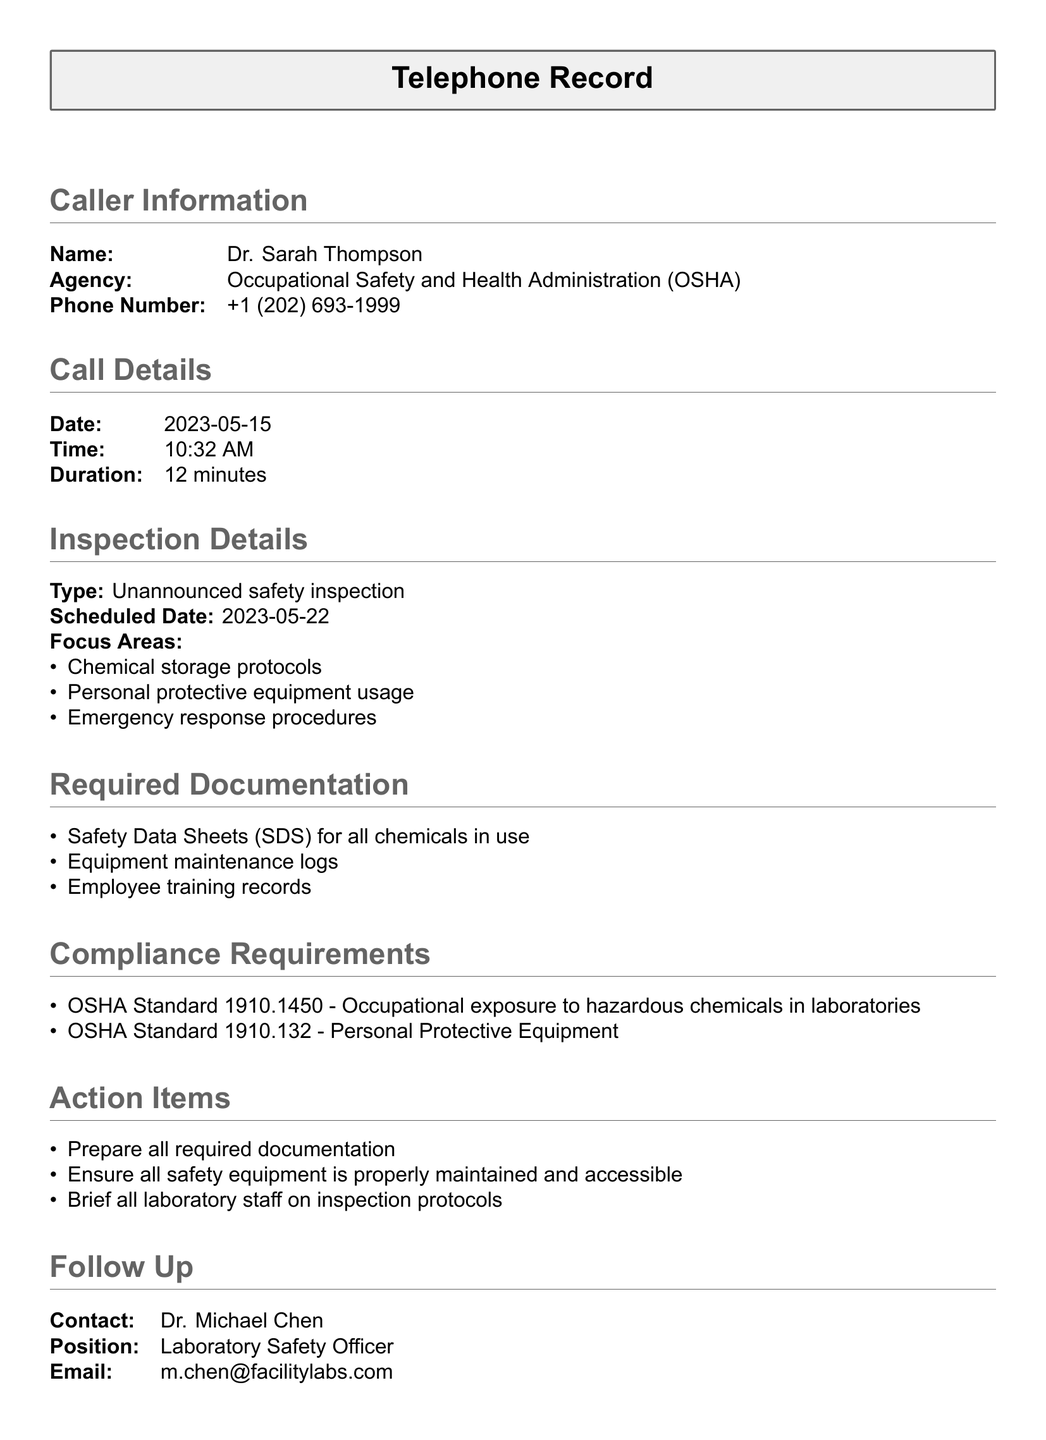What is the name of the caller? The caller's name is provided in the "Caller Information" section.
Answer: Dr. Sarah Thompson What agency does the caller represent? The agency is specified right after the caller's name.
Answer: Occupational Safety and Health Administration (OSHA) What is the date of the call? The date can be found in the "Call Details" section.
Answer: 2023-05-15 What type of inspection is scheduled? The type of inspection is listed under "Inspection Details."
Answer: Unannounced safety inspection How long was the call? The call duration is indicated in the "Call Details" section.
Answer: 12 minutes What are the focus areas of the inspection? The focus areas are listed as bullet points under "Inspection Details."
Answer: Chemical storage protocols, Personal protective equipment usage, Emergency response procedures What are the compliance requirements cited? Compliance requirements are provided under "Compliance Requirements."
Answer: OSHA Standard 1910.1450, OSHA Standard 1910.132 Who should be contacted for follow-up? The contact person for follow-up is stated in the "Follow Up" section.
Answer: Dr. Michael Chen 